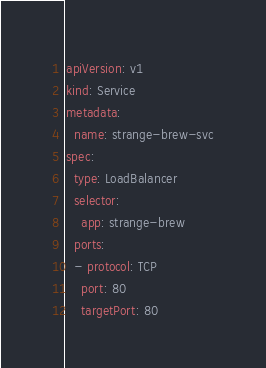<code> <loc_0><loc_0><loc_500><loc_500><_YAML_>apiVersion: v1
kind: Service
metadata:
  name: strange-brew-svc
spec:
  type: LoadBalancer
  selector:
    app: strange-brew
  ports:
  - protocol: TCP
    port: 80
    targetPort: 80</code> 